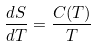<formula> <loc_0><loc_0><loc_500><loc_500>\frac { d S } { d T } = \frac { C ( T ) } { T }</formula> 